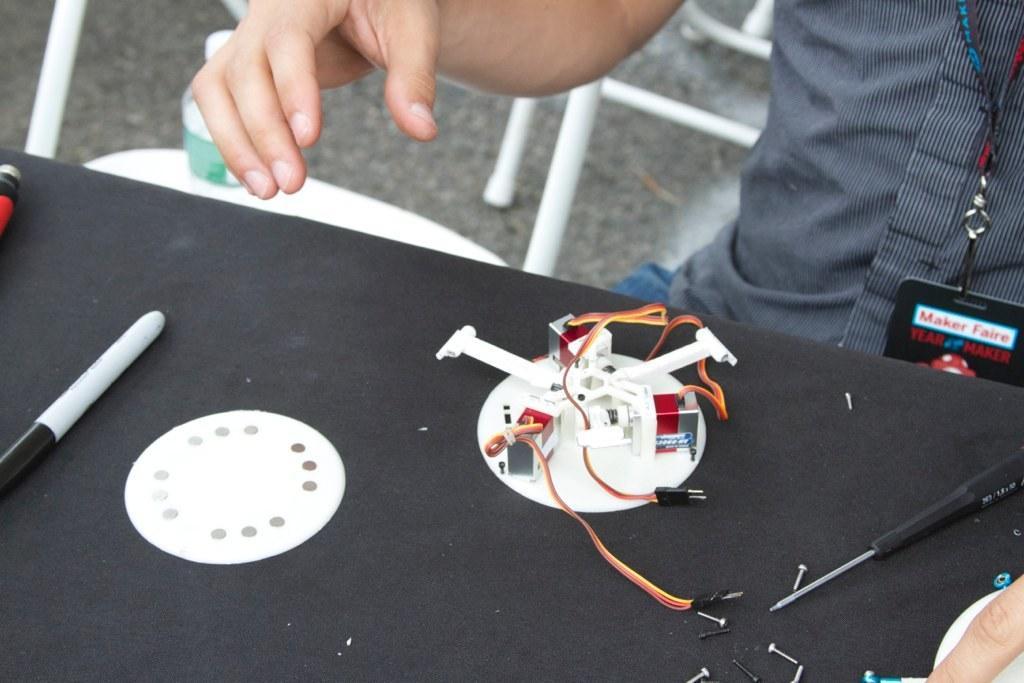How would you summarize this image in a sentence or two? In this image we can see a man sitting beside a table containing some electrical devices, a tool, a pen and some nails placed on it. On the backside we can see a bottle on a chair which is placed on the surface. 